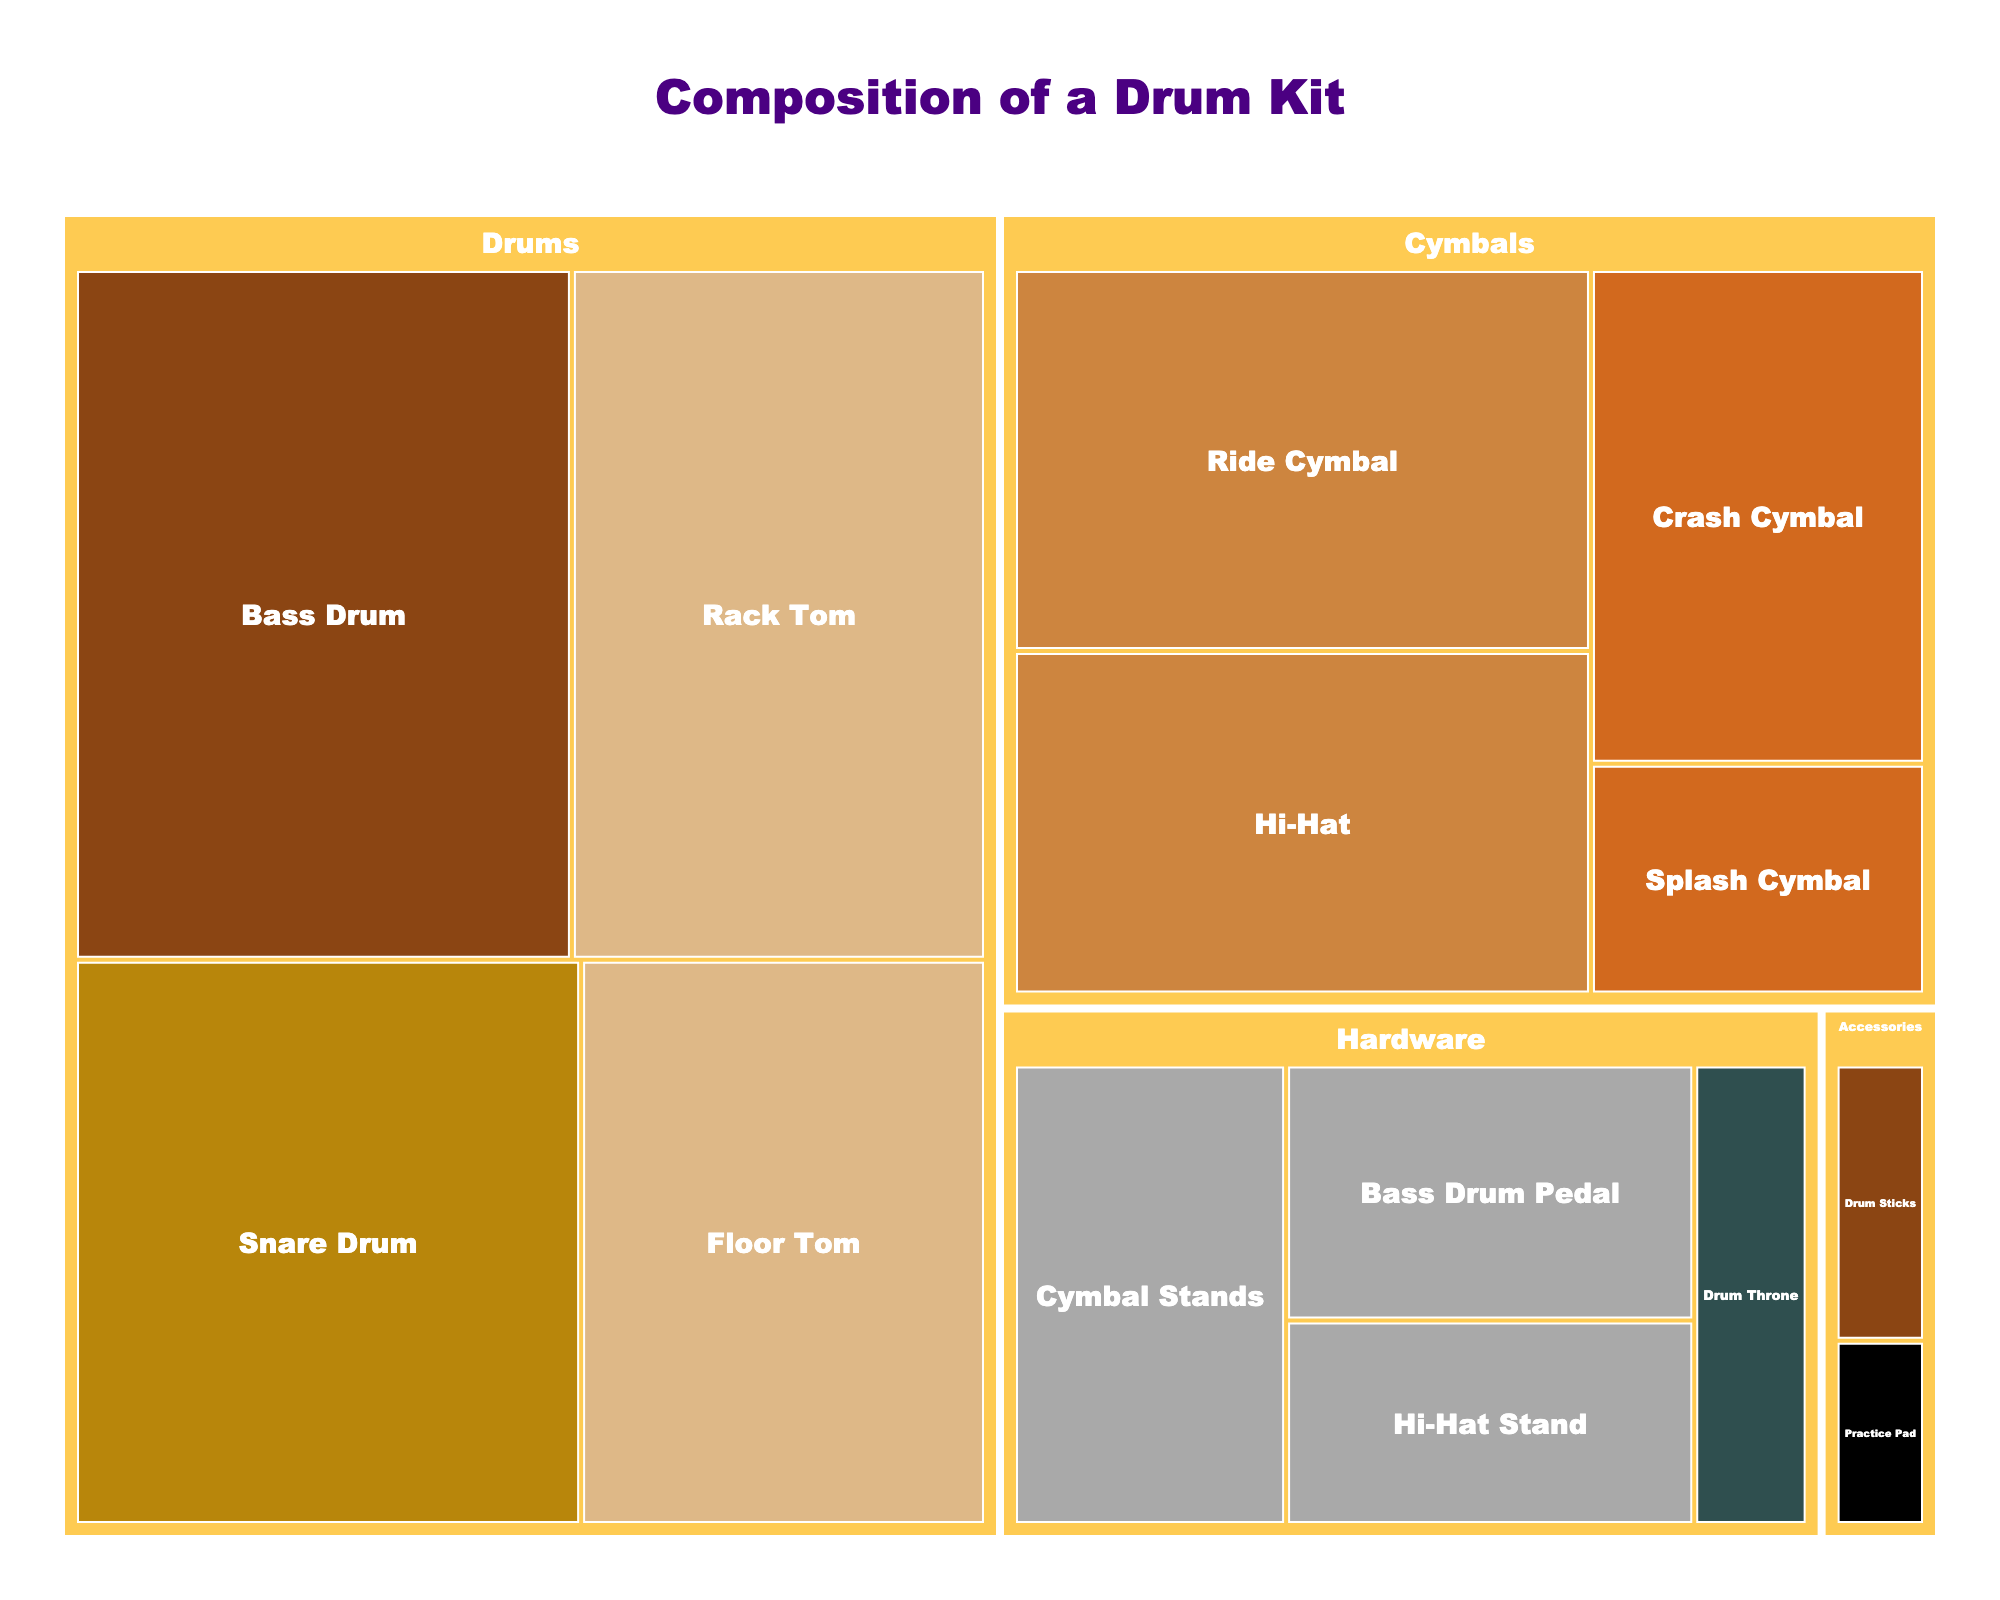What's the title of the treemap? Look at the top center of the treemap where the title is usually displayed.
Answer: Composition of a Drum Kit Which part has the highest value and what is its material? Identify the largest section in the treemap and check its label for the material. The largest section represents the part with the highest value.
Answer: Bass Drum, Maple How many types of cymbals are depicted in the treemap? Identify all sections under the 'Cymbals' category and count the distinct types.
Answer: 4 Which drum type is the smallest in value, and what's its size? Look for the smallest labeled section under the 'Drums' category and note its size.
Answer: Rack Tom, 10 inch Compare the sum of the values for 'Drums' made of Birch and Maple. Which is greater? Find the sections labeled 'Birch' and 'Maple' under the 'Drums' category, sum their values, and compare. Birch: 45 (16+15+10), Maple: 30 (30). Birch is greater.
Answer: Birch What is the material of the item's type with the value of 25? Identify the section with the value of 25 and check its label for the material.
Answer: Brass Sum the values of all parts under the 'Hardware' category. Locate all sections under the 'Hardware' category and add their values together: 10 (Bass Drum Pedal) + 8 (Hi-Hat Stand) + 12 (Cymbal Stands) + 5 (Drum Throne).
Answer: 35 Which category has the smallest total value and what is that value? Sum up the values within each category and identify the one with the least total. Accessories: 5 (Drum Sticks) + 2 (Practice Pad) = 7.
Answer: Accessories, 7 